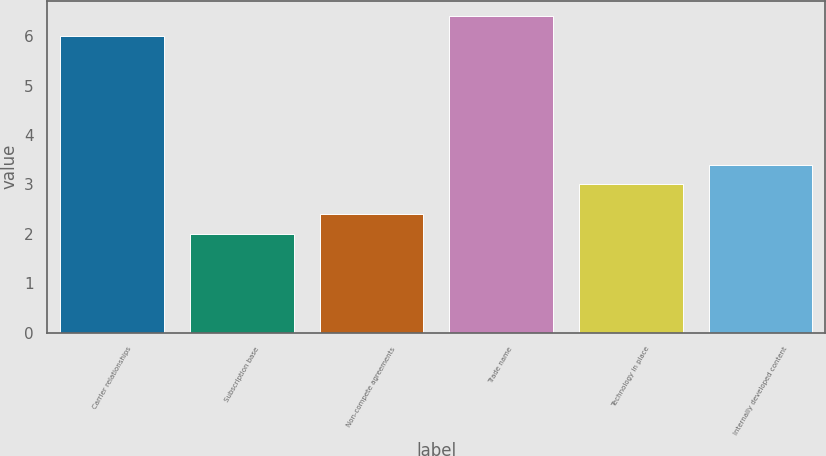<chart> <loc_0><loc_0><loc_500><loc_500><bar_chart><fcel>Carrier relationships<fcel>Subscription base<fcel>Non-compete agreements<fcel>Trade name<fcel>Technology in place<fcel>Internally developed content<nl><fcel>6<fcel>2<fcel>2.4<fcel>6.4<fcel>3<fcel>3.4<nl></chart> 